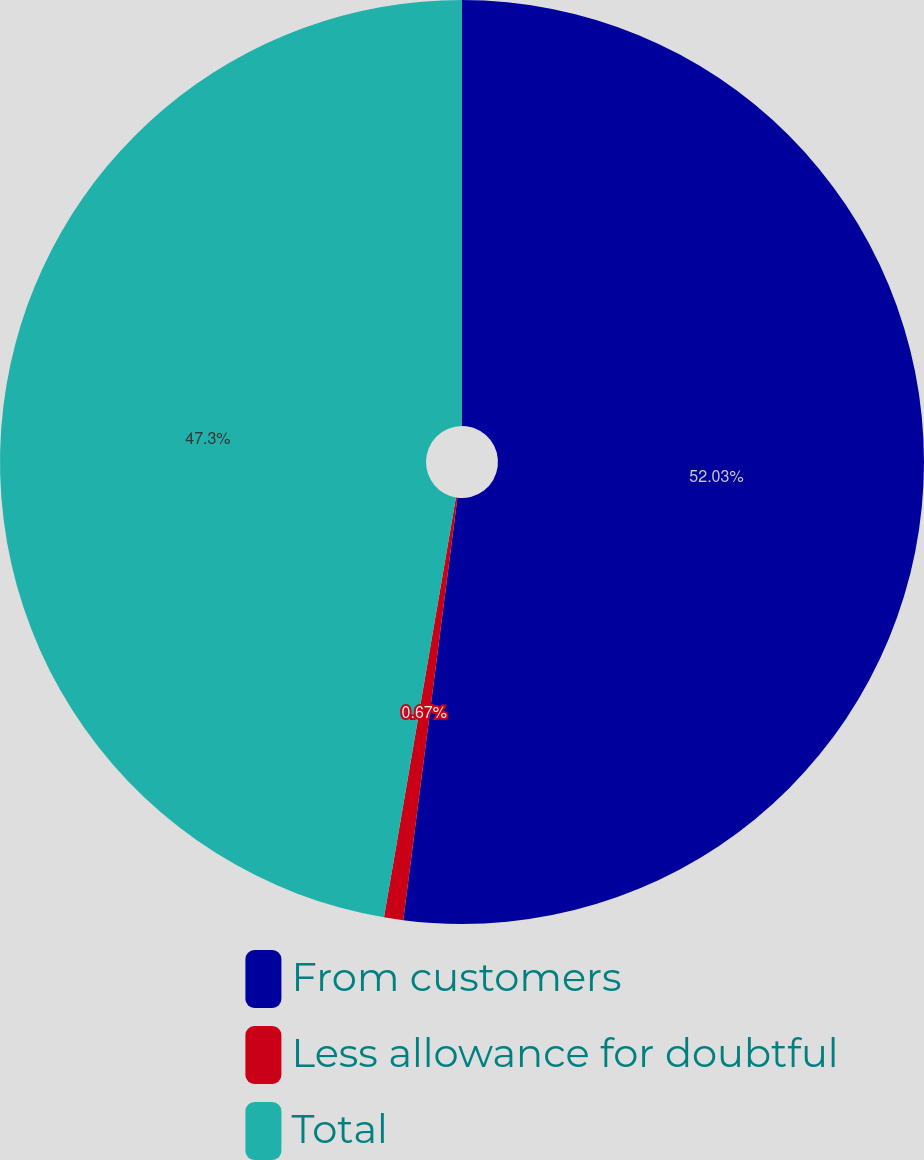Convert chart to OTSL. <chart><loc_0><loc_0><loc_500><loc_500><pie_chart><fcel>From customers<fcel>Less allowance for doubtful<fcel>Total<nl><fcel>52.03%<fcel>0.67%<fcel>47.3%<nl></chart> 